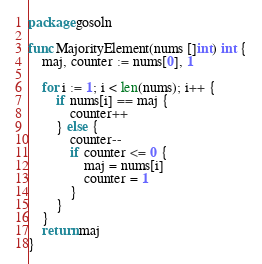Convert code to text. <code><loc_0><loc_0><loc_500><loc_500><_Go_>package gosoln

func MajorityElement(nums []int) int {
	maj, counter := nums[0], 1

	for i := 1; i < len(nums); i++ {
		if nums[i] == maj {
			counter++
		} else {
			counter--
			if counter <= 0 {
				maj = nums[i]
				counter = 1
			}
		}
	}
	return maj
}
</code> 